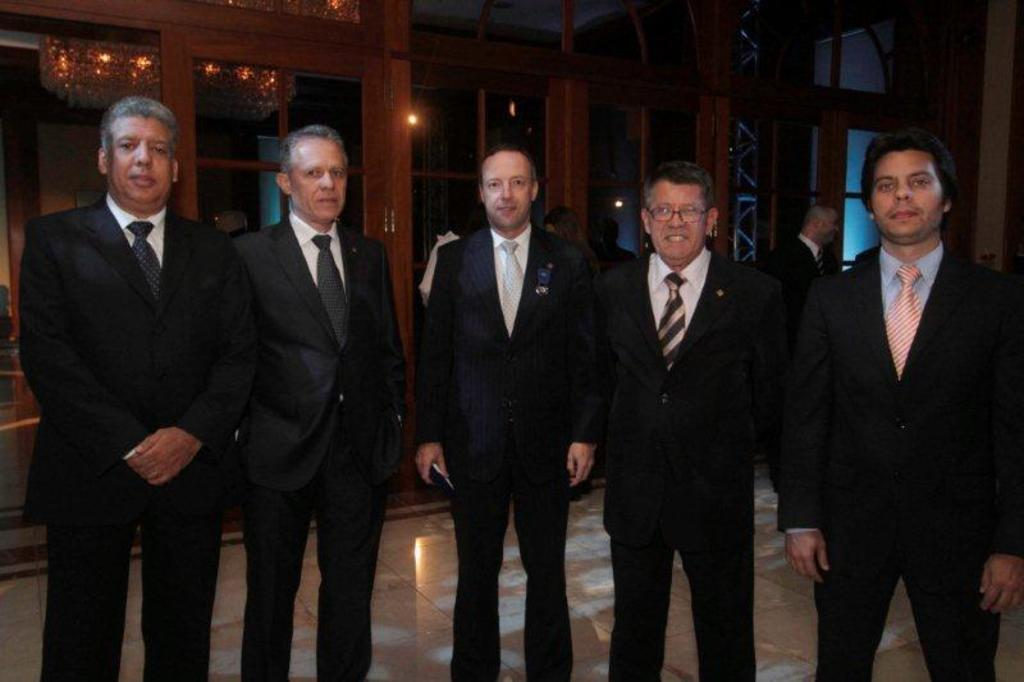How many men are present in the image? There are five men standing in the image. What are the men wearing? The men are wearing suits. What can be seen in the background of the image? There is a chandelier, people, and glass doors in the background of the image. How many children are playing with a horn in the image? There are no children or horns present in the image. 